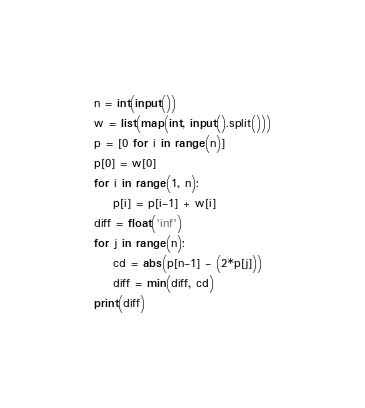Convert code to text. <code><loc_0><loc_0><loc_500><loc_500><_Python_>n = int(input())
w = list(map(int, input().split()))
p = [0 for i in range(n)]
p[0] = w[0]
for i in range(1, n):
    p[i] = p[i-1] + w[i]
diff = float('inf')
for j in range(n):
    cd = abs(p[n-1] - (2*p[j]))
    diff = min(diff, cd)
print(diff)</code> 